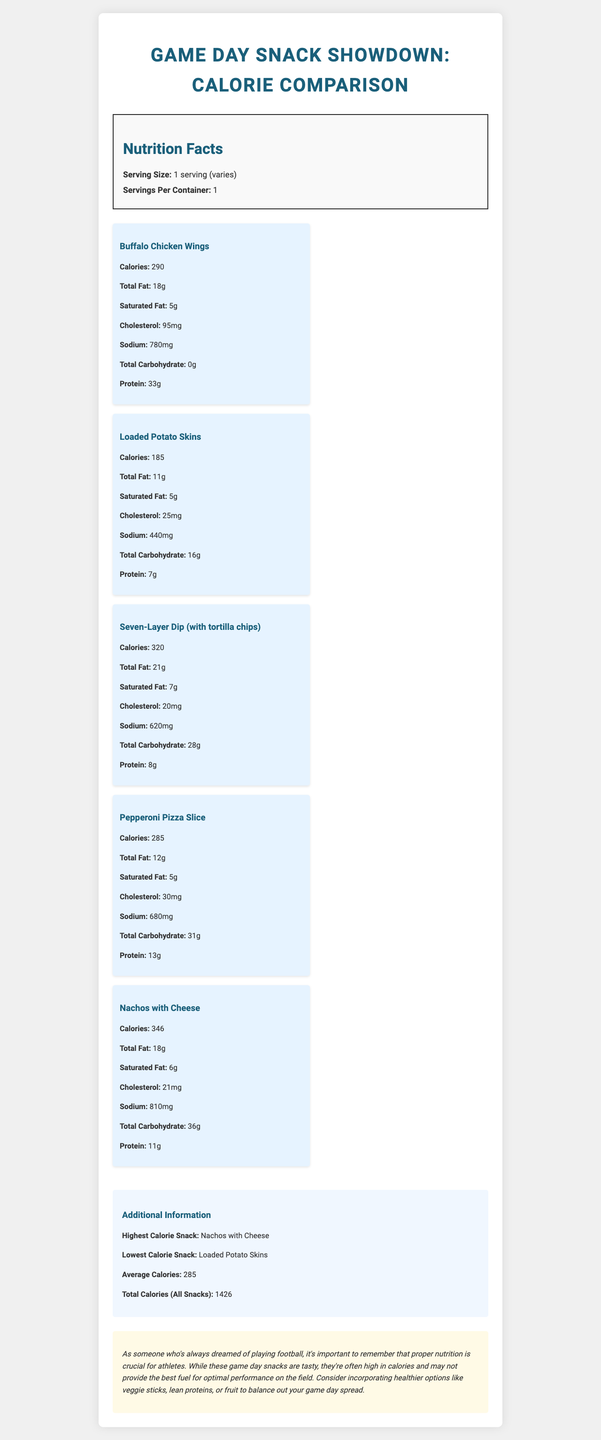what is the highest calorie snack? The document states in the additional information section that the highest calorie snack is Nachos with Cheese.
Answer: Nachos with Cheese which snack has the highest sodium content? The snack item details show that Nachos with Cheese contains 810 mg of sodium, which is the highest among all listed snacks.
Answer: Nachos with Cheese how many grams of saturated fat are in a Seven-Layer Dip serving? According to the snack items section, Seven-Layer Dip has 7 grams of saturated fat.
Answer: 7 grams what is the serving size for each snack? The nutrition label section states that the serving size is 1 serving, but it does not specify the exact quantity for each snack as it varies.
Answer: 1 serving (varies) what is the average calorie content across all snacks? The additional information section provides that the average calorie content across all snacks is 285 calories.
Answer: 285 calories which snack has the lowest calorie content? A. Buffalo Chicken Wings B. Loaded Potato Skins C. Seven-Layer Dip D. Pepperoni Pizza Slice Loaded Potato Skins have the lowest calorie content at 185 calories.
Answer: B what is the total cholesterol level in a serving of Buffalo Chicken Wings? The snack item section indicates that Buffalo Chicken Wings contain 95 mg of cholesterol per serving.
Answer: 95 mg is the total calorie content of all snacks above 1400? The additional information section mentions that the total calories from all snacks is 1426, which is above 1400.
Answer: Yes describe the document's main idea. The document offers a comprehensive calorie comparison of five popular game day snacks, stating their nutritional information, identifying which snack has the highest and lowest calories, and stressing the importance of healthy snack options for athletes.
Answer: The document compares the caloric content and other nutritional values of popular game day snacks. It highlights the snacks with the highest and lowest calories and provides additional nutrition-related insights and recommendations for healthier snacking options. can you determine the exact quantity of one serving for each snack? The document specifies the serving size as "1 serving (varies)" but does not provide the exact measurements or quantities for each snack serving.
Answer: Not enough information how many snacks contain at least 5 grams of saturated fat? A. 2 B. 3 C. 4 D. 5 The document states that Buffalo Chicken Wings (5 grams), Loaded Potato Skins (5 grams), Seven-Layer Dip (7 grams), and Pepperoni Pizza Slice (5 grams) contain at least 5 grams of saturated fat, totaling 4 snacks.
Answer: C how much protein does a serving of Pepperoni Pizza Slice contain? According to the snack item section, a serving of Pepperoni Pizza Slice contains 13 grams of protein.
Answer: 13 grams which snack has the highest carbohydrate content? The Nachos with Cheese contain 36 grams of carbohydrates, which is the highest among the listed snacks.
Answer: Nachos with Cheese what's the combined calorie count of the two highest-calorie snacks? Nachos with Cheese has 346 calories and Seven-Layer Dip has 320 calories. Combined, they total 666 calories (346 + 320 = 666).
Answer: 666 calories do Loaded Potato Skins have more protein than Seven-Layer Dip? The Loaded Potato Skins have 7 grams of protein, while the Seven-Layer Dip has 8 grams of protein, making the Seven-Layer Dip higher in protein content.
Answer: No 